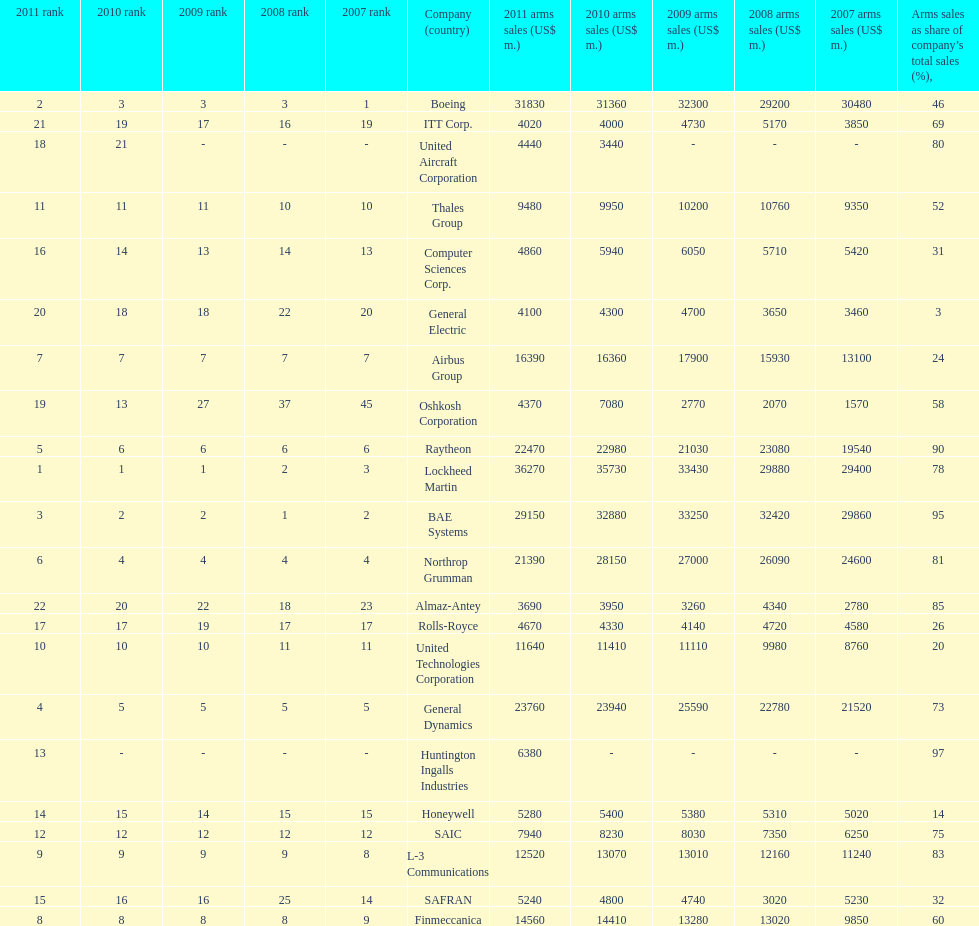Calculate the difference between boeing's 2010 arms sales and raytheon's 2010 arms sales. 8380. 